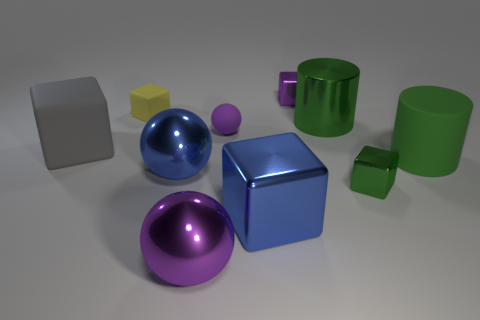What is the shape of the small thing that is the same color as the large rubber cylinder?
Your response must be concise. Cube. Are there more cylinders than metallic objects?
Offer a terse response. No. There is a big thing that is to the left of the big shiny sphere that is left of the purple metal thing in front of the green metallic cylinder; what color is it?
Offer a very short reply. Gray. Do the small rubber object that is in front of the small yellow cube and the big purple object have the same shape?
Your answer should be compact. Yes. There is a rubber block that is the same size as the green rubber thing; what is its color?
Provide a succinct answer. Gray. What number of big yellow matte balls are there?
Ensure brevity in your answer.  0. Is the material of the purple thing behind the tiny yellow rubber block the same as the large gray block?
Offer a terse response. No. The tiny thing that is in front of the yellow object and behind the gray cube is made of what material?
Keep it short and to the point. Rubber. What size is the other ball that is the same color as the small ball?
Provide a short and direct response. Large. There is a ball that is behind the large rubber thing on the right side of the purple metal sphere; what is it made of?
Provide a short and direct response. Rubber. 